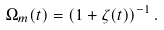Convert formula to latex. <formula><loc_0><loc_0><loc_500><loc_500>\Omega _ { m } ( t ) = ( 1 + \zeta ( t ) ) ^ { - 1 } \, .</formula> 